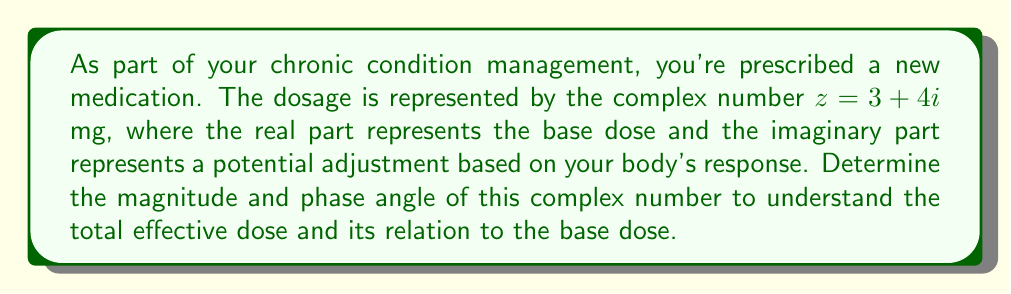Give your solution to this math problem. To find the magnitude and phase angle of the complex number $z = 3 + 4i$, we'll use the following formulas:

1. Magnitude: $|z| = \sqrt{a^2 + b^2}$, where $a$ is the real part and $b$ is the imaginary part.
2. Phase angle: $\theta = \tan^{-1}(\frac{b}{a})$, where $a$ is the real part and $b$ is the imaginary part.

Step 1: Calculate the magnitude
$$|z| = \sqrt{3^2 + 4^2} = \sqrt{9 + 16} = \sqrt{25} = 5$$

Step 2: Calculate the phase angle
$$\theta = \tan^{-1}(\frac{4}{3}) \approx 0.9273 \text{ radians}$$

To convert radians to degrees, multiply by $\frac{180°}{\pi}$:
$$0.9273 \times \frac{180°}{\pi} \approx 53.13°$$

The magnitude represents the total effective dose, which is 5 mg.
The phase angle of approximately 53.13° represents the angle between the base dose (real part) and the total effective dose in the complex plane.
Answer: Magnitude: 5 mg
Phase angle: approximately 53.13° 